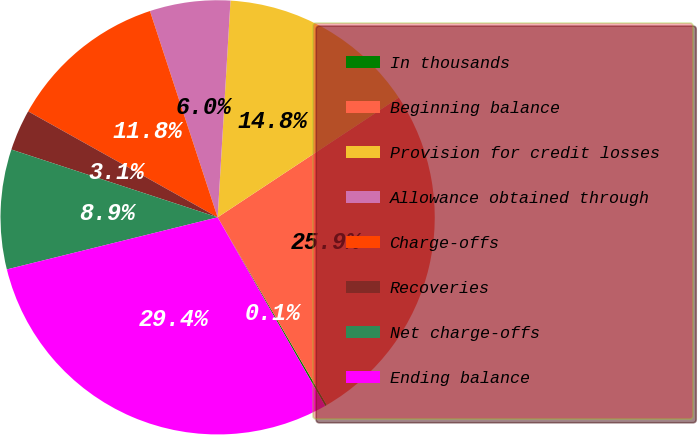Convert chart. <chart><loc_0><loc_0><loc_500><loc_500><pie_chart><fcel>In thousands<fcel>Beginning balance<fcel>Provision for credit losses<fcel>Allowance obtained through<fcel>Charge-offs<fcel>Recoveries<fcel>Net charge-offs<fcel>Ending balance<nl><fcel>0.14%<fcel>25.91%<fcel>14.76%<fcel>5.99%<fcel>11.84%<fcel>3.06%<fcel>8.91%<fcel>29.39%<nl></chart> 